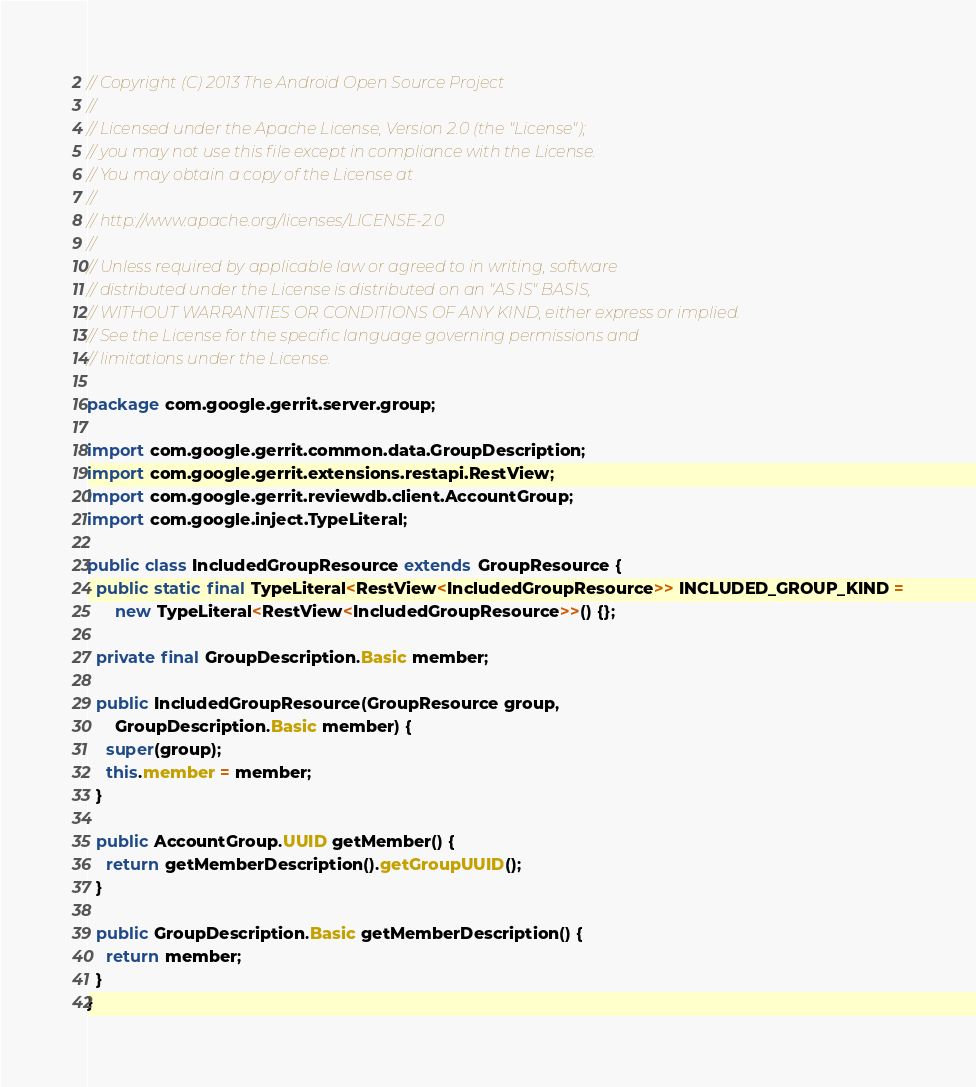<code> <loc_0><loc_0><loc_500><loc_500><_Java_>// Copyright (C) 2013 The Android Open Source Project
//
// Licensed under the Apache License, Version 2.0 (the "License");
// you may not use this file except in compliance with the License.
// You may obtain a copy of the License at
//
// http://www.apache.org/licenses/LICENSE-2.0
//
// Unless required by applicable law or agreed to in writing, software
// distributed under the License is distributed on an "AS IS" BASIS,
// WITHOUT WARRANTIES OR CONDITIONS OF ANY KIND, either express or implied.
// See the License for the specific language governing permissions and
// limitations under the License.

package com.google.gerrit.server.group;

import com.google.gerrit.common.data.GroupDescription;
import com.google.gerrit.extensions.restapi.RestView;
import com.google.gerrit.reviewdb.client.AccountGroup;
import com.google.inject.TypeLiteral;

public class IncludedGroupResource extends GroupResource {
  public static final TypeLiteral<RestView<IncludedGroupResource>> INCLUDED_GROUP_KIND =
      new TypeLiteral<RestView<IncludedGroupResource>>() {};

  private final GroupDescription.Basic member;

  public IncludedGroupResource(GroupResource group,
      GroupDescription.Basic member) {
    super(group);
    this.member = member;
  }

  public AccountGroup.UUID getMember() {
    return getMemberDescription().getGroupUUID();
  }

  public GroupDescription.Basic getMemberDescription() {
    return member;
  }
}
</code> 